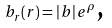Convert formula to latex. <formula><loc_0><loc_0><loc_500><loc_500>b _ { r } ( r ) = \left | b \right | e ^ { \rho } \text {,}</formula> 